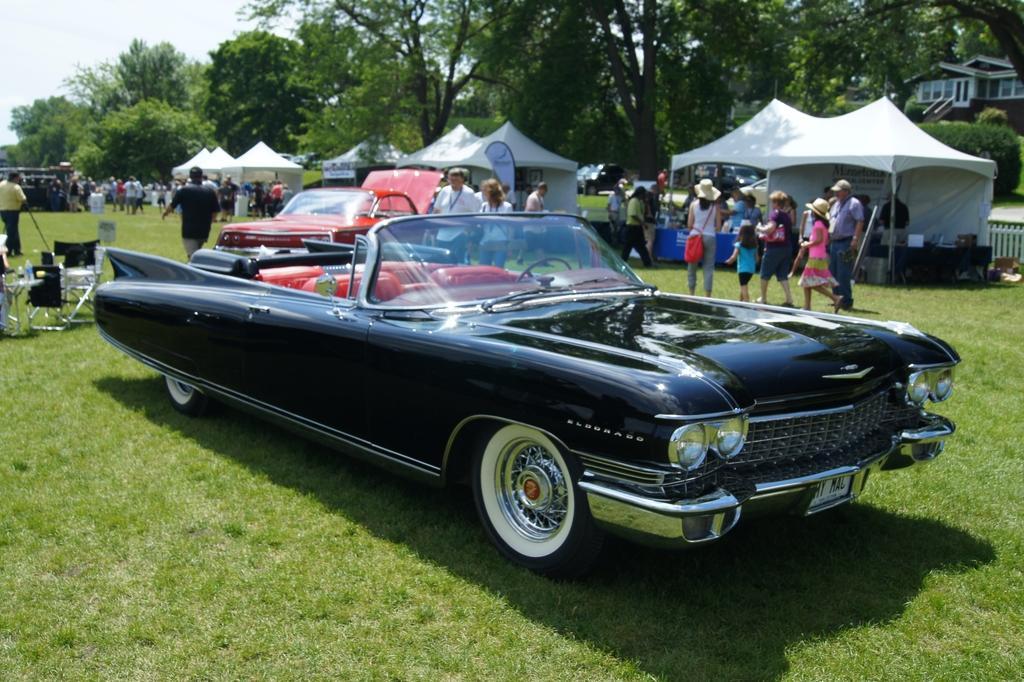In one or two sentences, can you explain what this image depicts? In this image we can see some cars and a group of people on the ground. We can also see some people under the tents, chairs, some objects on a table, a fence, a group of trees, a building and the sky. 